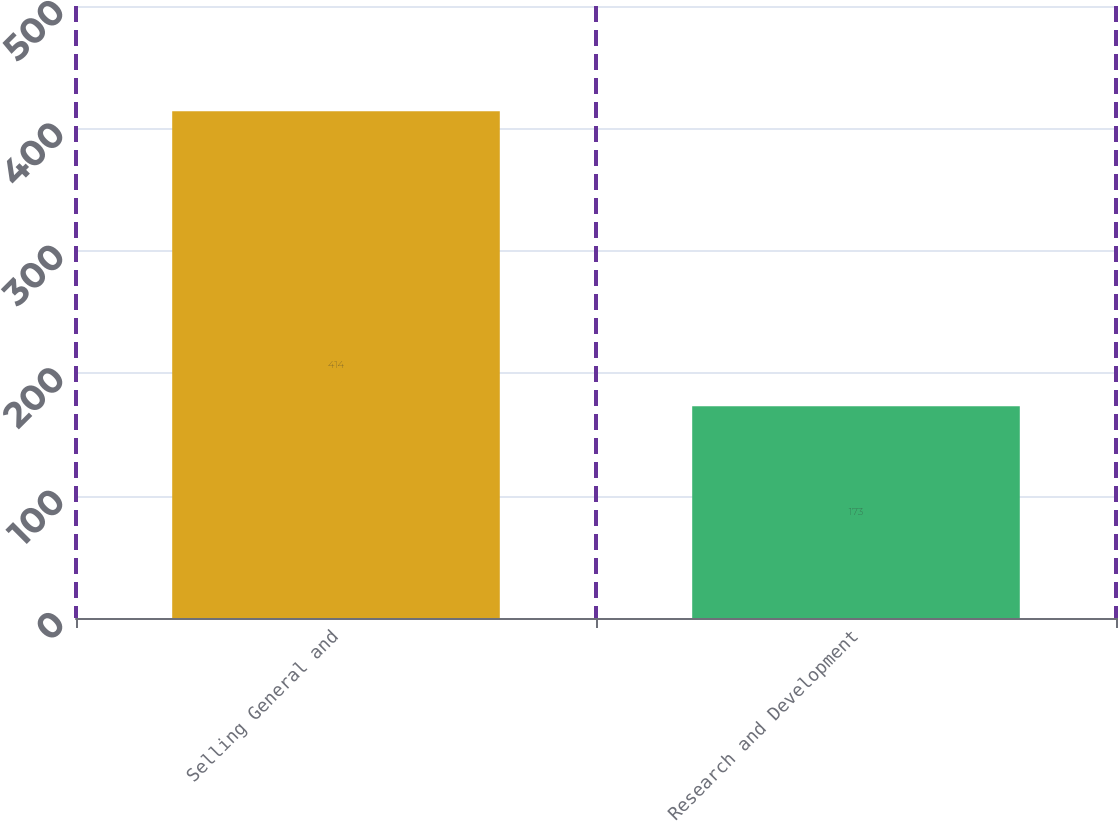<chart> <loc_0><loc_0><loc_500><loc_500><bar_chart><fcel>Selling General and<fcel>Research and Development<nl><fcel>414<fcel>173<nl></chart> 